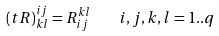<formula> <loc_0><loc_0><loc_500><loc_500>( t R ) ^ { i j } _ { k l } = R ^ { k l } _ { i j } \quad i , j , k , l = 1 . . q</formula> 